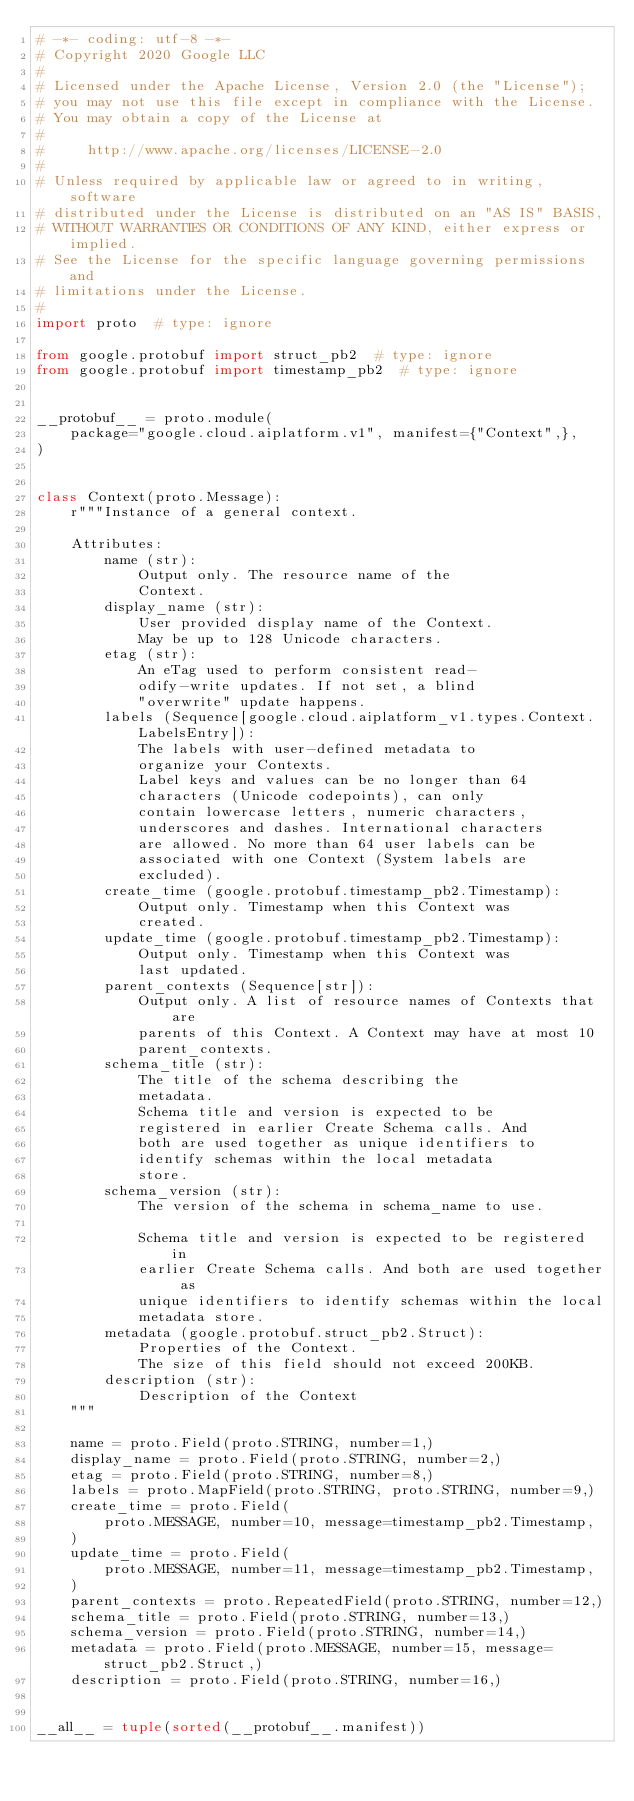<code> <loc_0><loc_0><loc_500><loc_500><_Python_># -*- coding: utf-8 -*-
# Copyright 2020 Google LLC
#
# Licensed under the Apache License, Version 2.0 (the "License");
# you may not use this file except in compliance with the License.
# You may obtain a copy of the License at
#
#     http://www.apache.org/licenses/LICENSE-2.0
#
# Unless required by applicable law or agreed to in writing, software
# distributed under the License is distributed on an "AS IS" BASIS,
# WITHOUT WARRANTIES OR CONDITIONS OF ANY KIND, either express or implied.
# See the License for the specific language governing permissions and
# limitations under the License.
#
import proto  # type: ignore

from google.protobuf import struct_pb2  # type: ignore
from google.protobuf import timestamp_pb2  # type: ignore


__protobuf__ = proto.module(
    package="google.cloud.aiplatform.v1", manifest={"Context",},
)


class Context(proto.Message):
    r"""Instance of a general context.

    Attributes:
        name (str):
            Output only. The resource name of the
            Context.
        display_name (str):
            User provided display name of the Context.
            May be up to 128 Unicode characters.
        etag (str):
            An eTag used to perform consistent read-
            odify-write updates. If not set, a blind
            "overwrite" update happens.
        labels (Sequence[google.cloud.aiplatform_v1.types.Context.LabelsEntry]):
            The labels with user-defined metadata to
            organize your Contexts.
            Label keys and values can be no longer than 64
            characters (Unicode codepoints), can only
            contain lowercase letters, numeric characters,
            underscores and dashes. International characters
            are allowed. No more than 64 user labels can be
            associated with one Context (System labels are
            excluded).
        create_time (google.protobuf.timestamp_pb2.Timestamp):
            Output only. Timestamp when this Context was
            created.
        update_time (google.protobuf.timestamp_pb2.Timestamp):
            Output only. Timestamp when this Context was
            last updated.
        parent_contexts (Sequence[str]):
            Output only. A list of resource names of Contexts that are
            parents of this Context. A Context may have at most 10
            parent_contexts.
        schema_title (str):
            The title of the schema describing the
            metadata.
            Schema title and version is expected to be
            registered in earlier Create Schema calls. And
            both are used together as unique identifiers to
            identify schemas within the local metadata
            store.
        schema_version (str):
            The version of the schema in schema_name to use.

            Schema title and version is expected to be registered in
            earlier Create Schema calls. And both are used together as
            unique identifiers to identify schemas within the local
            metadata store.
        metadata (google.protobuf.struct_pb2.Struct):
            Properties of the Context.
            The size of this field should not exceed 200KB.
        description (str):
            Description of the Context
    """

    name = proto.Field(proto.STRING, number=1,)
    display_name = proto.Field(proto.STRING, number=2,)
    etag = proto.Field(proto.STRING, number=8,)
    labels = proto.MapField(proto.STRING, proto.STRING, number=9,)
    create_time = proto.Field(
        proto.MESSAGE, number=10, message=timestamp_pb2.Timestamp,
    )
    update_time = proto.Field(
        proto.MESSAGE, number=11, message=timestamp_pb2.Timestamp,
    )
    parent_contexts = proto.RepeatedField(proto.STRING, number=12,)
    schema_title = proto.Field(proto.STRING, number=13,)
    schema_version = proto.Field(proto.STRING, number=14,)
    metadata = proto.Field(proto.MESSAGE, number=15, message=struct_pb2.Struct,)
    description = proto.Field(proto.STRING, number=16,)


__all__ = tuple(sorted(__protobuf__.manifest))
</code> 